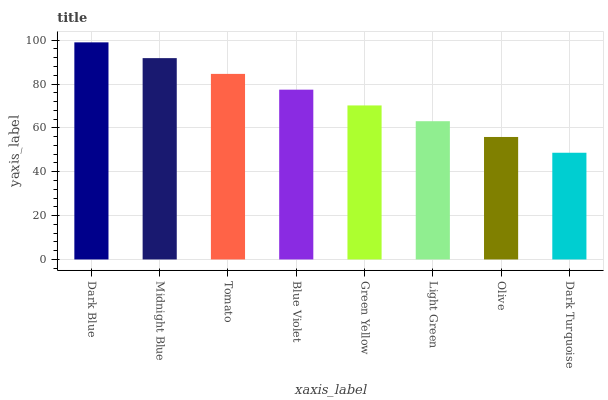Is Dark Blue the maximum?
Answer yes or no. Yes. Is Midnight Blue the minimum?
Answer yes or no. No. Is Midnight Blue the maximum?
Answer yes or no. No. Is Dark Blue greater than Midnight Blue?
Answer yes or no. Yes. Is Midnight Blue less than Dark Blue?
Answer yes or no. Yes. Is Midnight Blue greater than Dark Blue?
Answer yes or no. No. Is Dark Blue less than Midnight Blue?
Answer yes or no. No. Is Blue Violet the high median?
Answer yes or no. Yes. Is Green Yellow the low median?
Answer yes or no. Yes. Is Tomato the high median?
Answer yes or no. No. Is Light Green the low median?
Answer yes or no. No. 